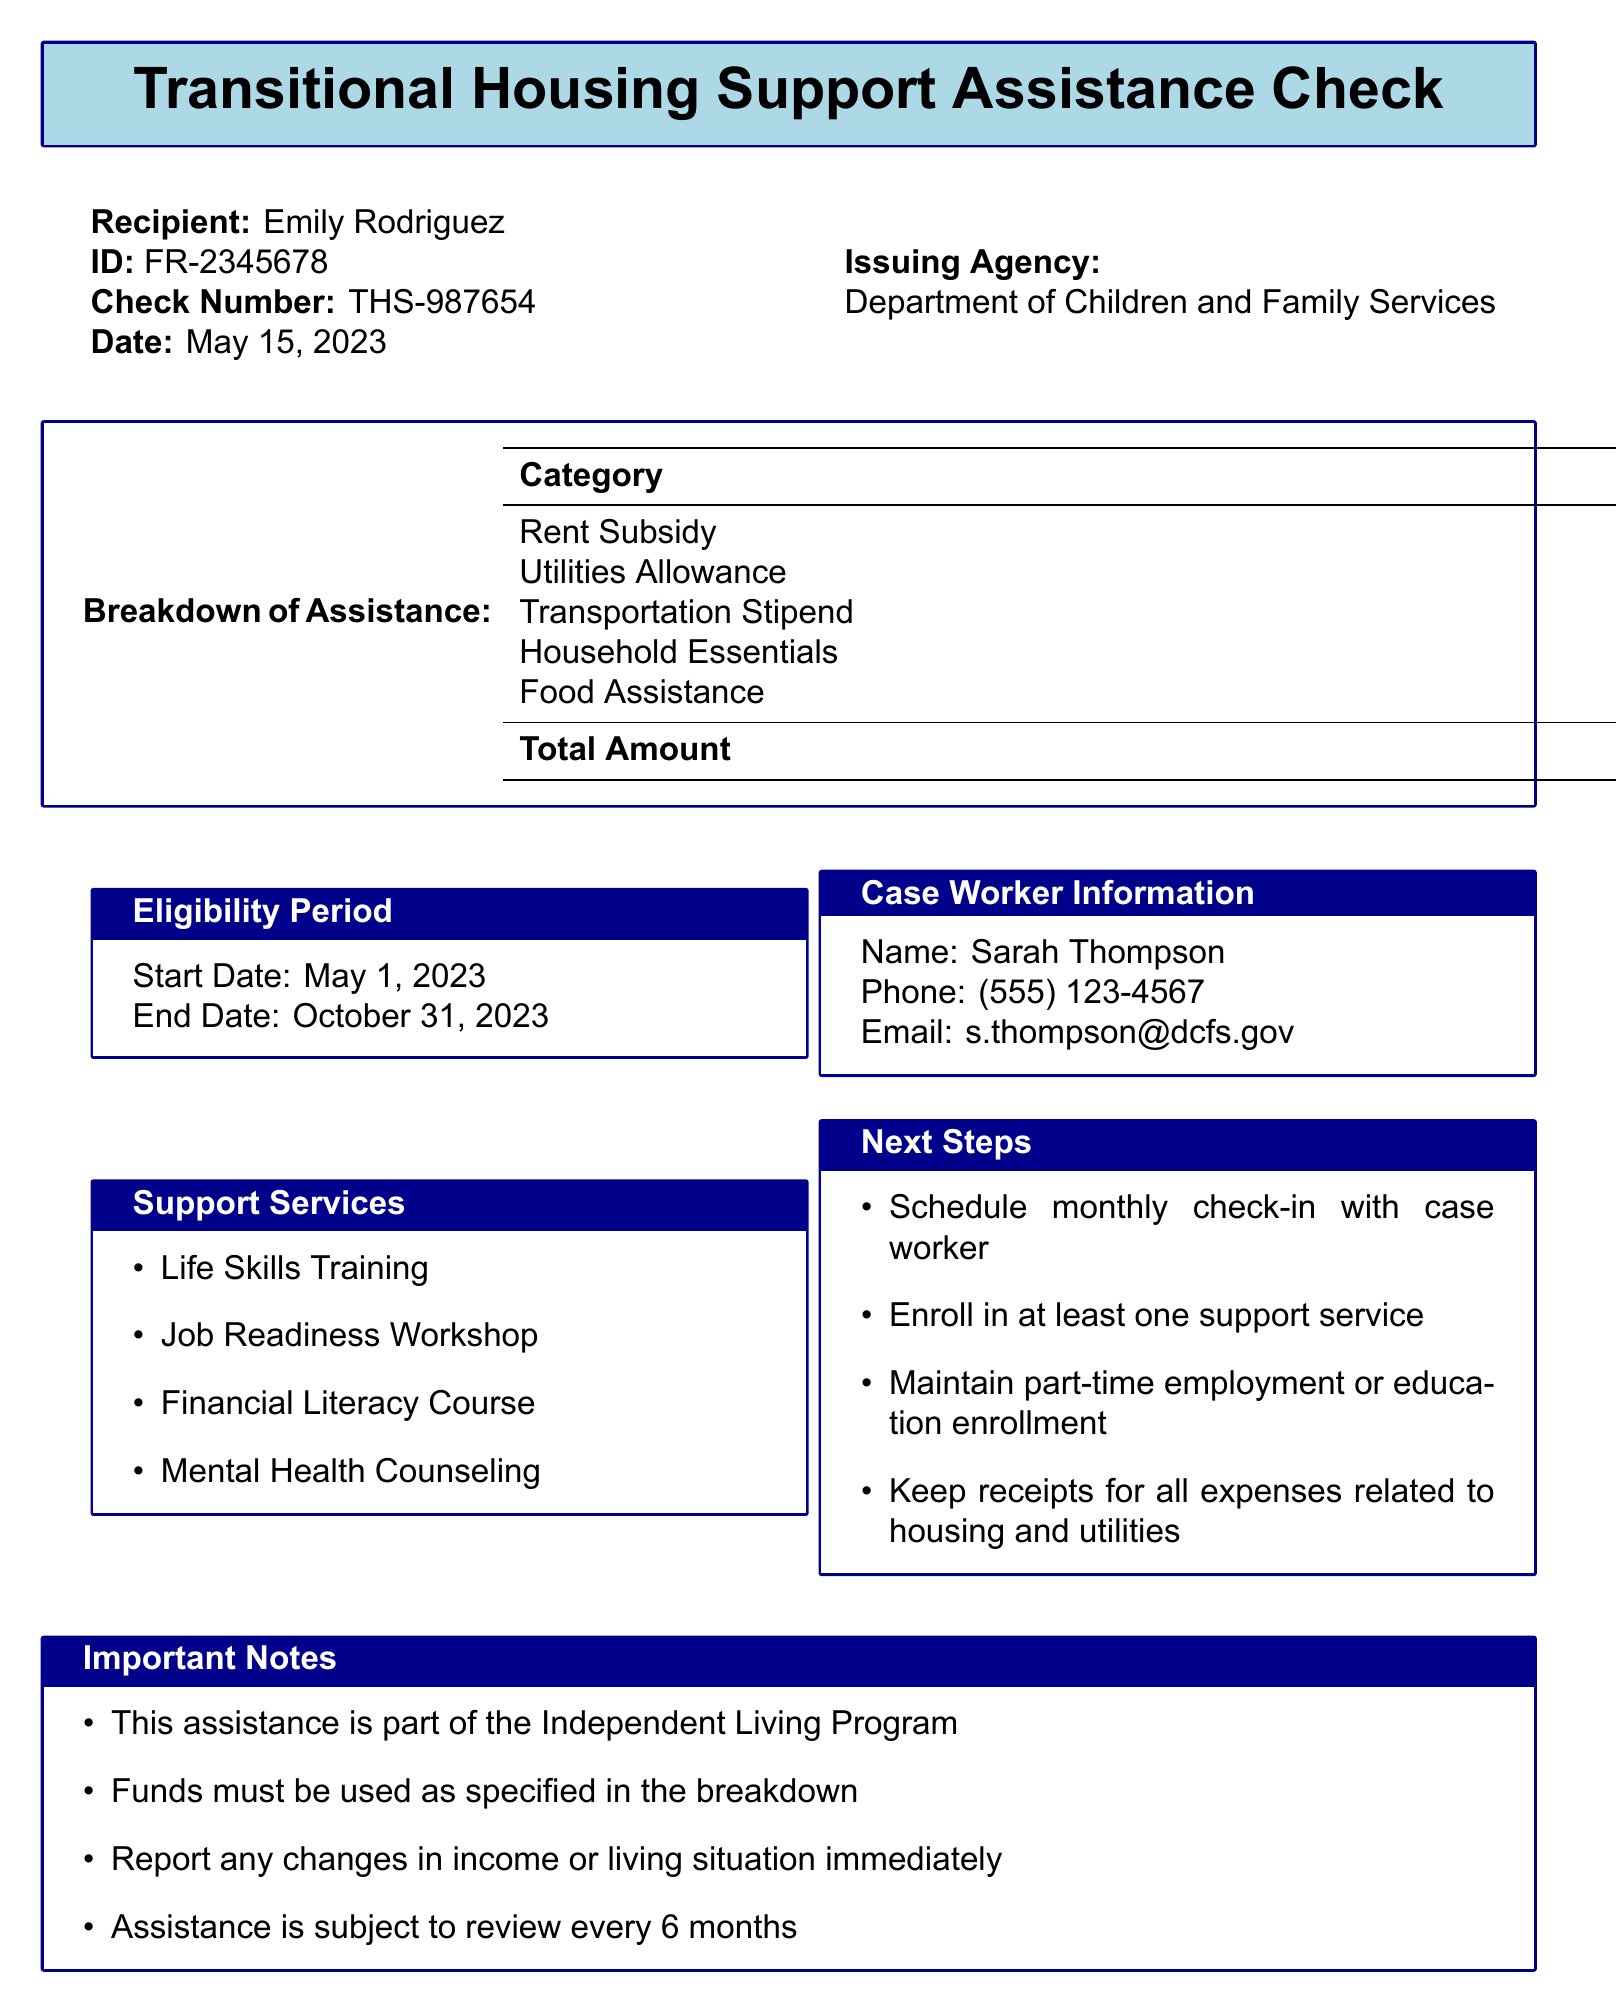What is the recipient's name? The document explicitly states the recipient's name as Emily Rodriguez.
Answer: Emily Rodriguez What is the total amount of the assistance check? The total amount listed in the document is $1275.00.
Answer: $1275.00 Who is the case worker for this assistance? The case worker's name provided in the document is Sarah Thompson.
Answer: Sarah Thompson What is the start date of the eligibility period? The document indicates that the eligibility period starts on May 1, 2023.
Answer: May 1, 2023 What category has the highest amount in the breakdown? The highest amount in the breakdown is associated with the Rent Subsidy category, which is $850.00.
Answer: Rent Subsidy How many support services are listed in the document? The document lists four support services available.
Answer: four What must be scheduled to follow up with the case worker? The next step requires scheduling a monthly check-in with the case worker.
Answer: monthly check-in What is one important note regarding the use of funds? The document specifies that funds must be used as specified in the breakdown.
Answer: Funds must be used as specified in the breakdown What type of program is this assistance part of? The document notes that this assistance is part of the Independent Living Program.
Answer: Independent Living Program 